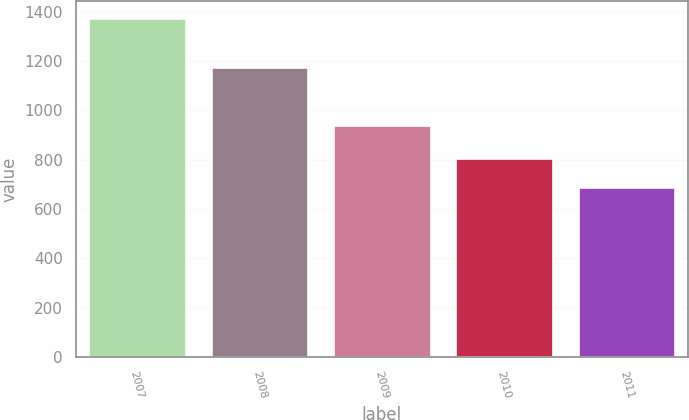<chart> <loc_0><loc_0><loc_500><loc_500><bar_chart><fcel>2007<fcel>2008<fcel>2009<fcel>2010<fcel>2011<nl><fcel>1374<fcel>1176<fcel>940<fcel>805<fcel>690<nl></chart> 